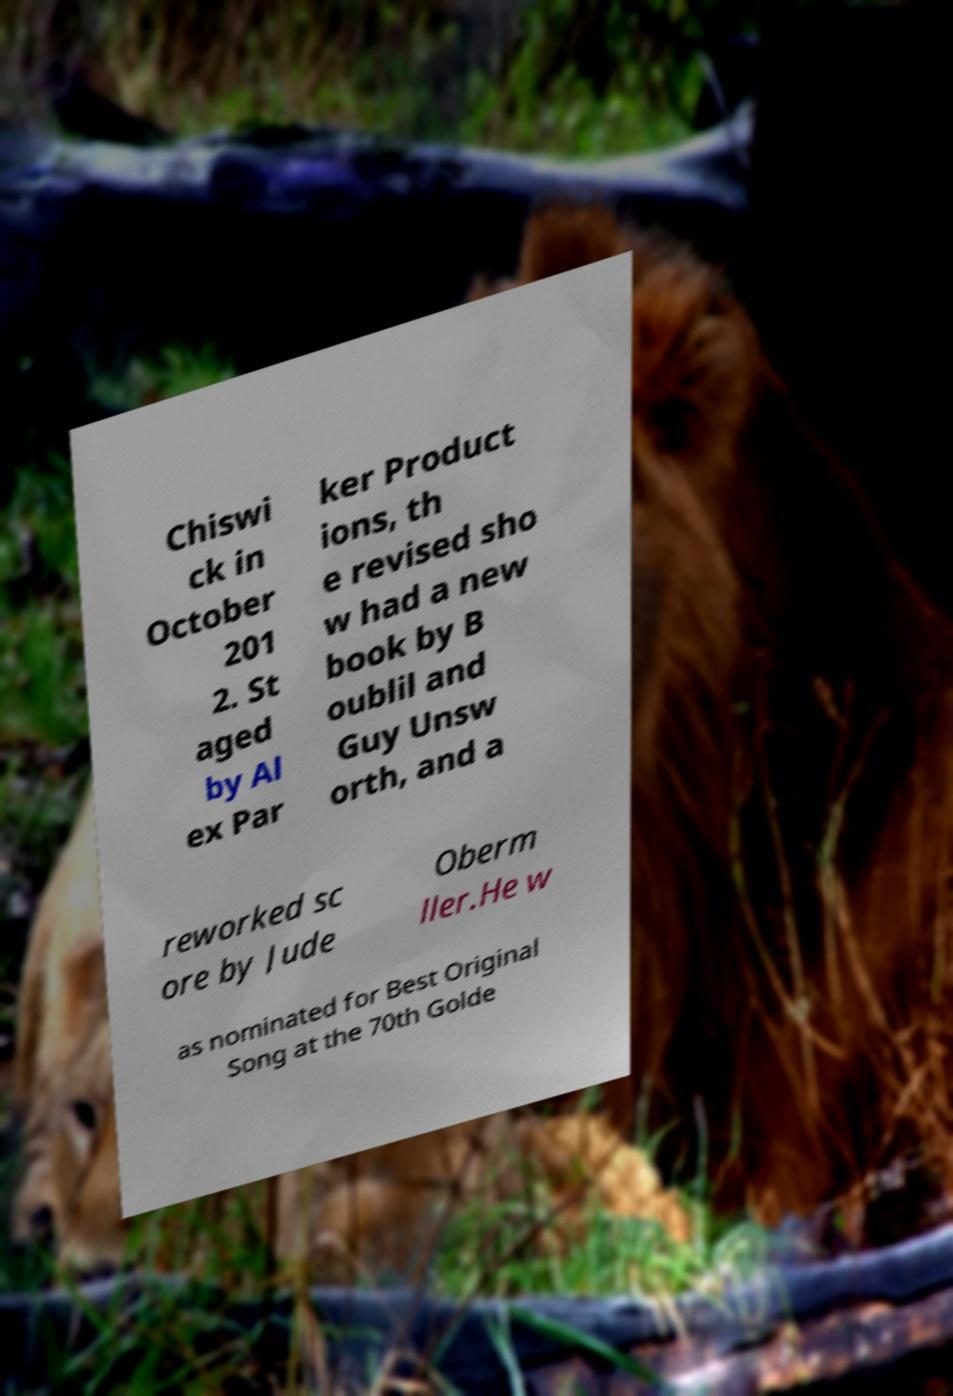Please identify and transcribe the text found in this image. Chiswi ck in October 201 2. St aged by Al ex Par ker Product ions, th e revised sho w had a new book by B oublil and Guy Unsw orth, and a reworked sc ore by Jude Oberm ller.He w as nominated for Best Original Song at the 70th Golde 